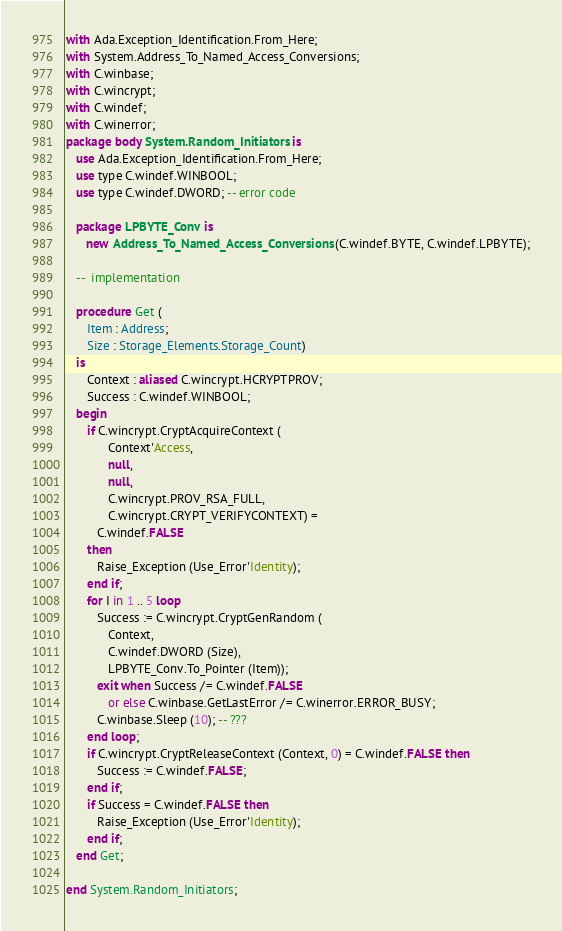<code> <loc_0><loc_0><loc_500><loc_500><_Ada_>with Ada.Exception_Identification.From_Here;
with System.Address_To_Named_Access_Conversions;
with C.winbase;
with C.wincrypt;
with C.windef;
with C.winerror;
package body System.Random_Initiators is
   use Ada.Exception_Identification.From_Here;
   use type C.windef.WINBOOL;
   use type C.windef.DWORD; -- error code

   package LPBYTE_Conv is
      new Address_To_Named_Access_Conversions (C.windef.BYTE, C.windef.LPBYTE);

   --  implementation

   procedure Get (
      Item : Address;
      Size : Storage_Elements.Storage_Count)
   is
      Context : aliased C.wincrypt.HCRYPTPROV;
      Success : C.windef.WINBOOL;
   begin
      if C.wincrypt.CryptAcquireContext (
            Context'Access,
            null,
            null,
            C.wincrypt.PROV_RSA_FULL,
            C.wincrypt.CRYPT_VERIFYCONTEXT) =
         C.windef.FALSE
      then
         Raise_Exception (Use_Error'Identity);
      end if;
      for I in 1 .. 5 loop
         Success := C.wincrypt.CryptGenRandom (
            Context,
            C.windef.DWORD (Size),
            LPBYTE_Conv.To_Pointer (Item));
         exit when Success /= C.windef.FALSE
            or else C.winbase.GetLastError /= C.winerror.ERROR_BUSY;
         C.winbase.Sleep (10); -- ???
      end loop;
      if C.wincrypt.CryptReleaseContext (Context, 0) = C.windef.FALSE then
         Success := C.windef.FALSE;
      end if;
      if Success = C.windef.FALSE then
         Raise_Exception (Use_Error'Identity);
      end if;
   end Get;

end System.Random_Initiators;
</code> 